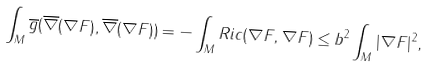Convert formula to latex. <formula><loc_0><loc_0><loc_500><loc_500>\int _ { M } \overline { g } ( \overline { \nabla } ( \nabla F ) , \overline { \nabla } ( \nabla F ) ) = - \int _ { M } R i c ( \nabla F , \nabla F ) \leq b ^ { 2 } \int _ { M } | \nabla F | ^ { 2 } ,</formula> 